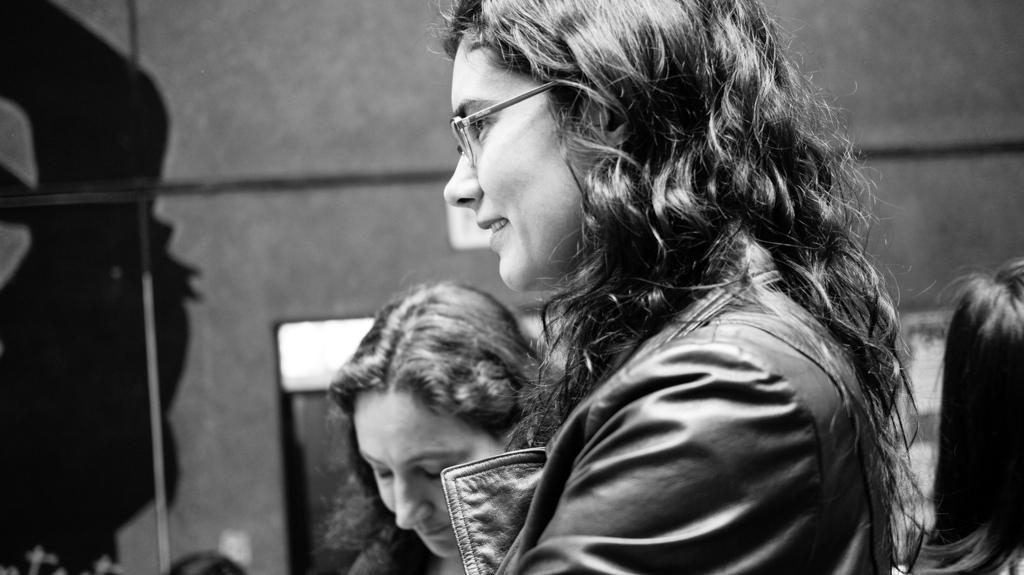Who or what is present in the image? There are people in the image. What can be seen in the background of the image? There is a wall in the background of the image. What type of ghost is visible in the image? There is no ghost present in the image; only people and a wall are visible. What kind of bag is being carried by the people in the image? The provided facts do not mention any bags being carried by the people in the image. 